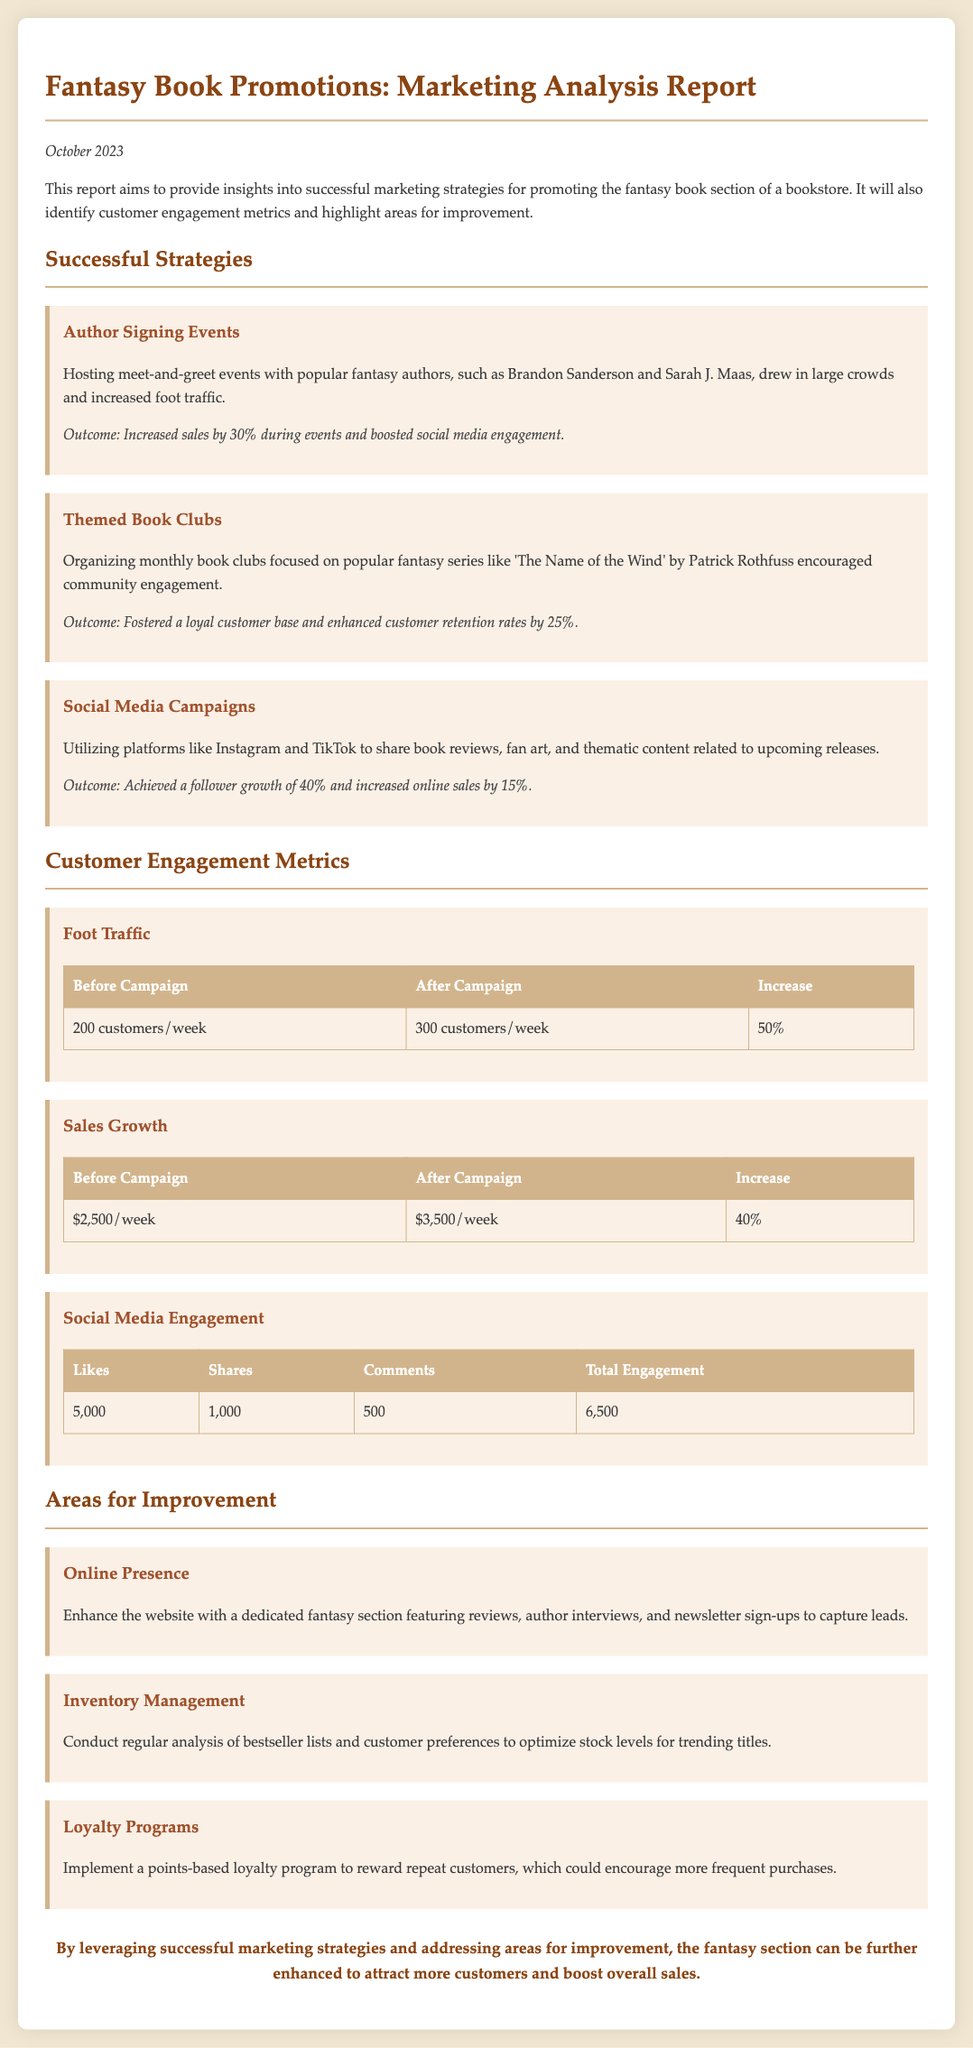what was the increase in foot traffic? The document states an increase of 50% in foot traffic after the marketing campaign.
Answer: 50% who are two popular fantasy authors mentioned? The report highlights Brandon Sanderson and Sarah J. Maas as popular fantasy authors.
Answer: Brandon Sanderson and Sarah J. Maas what is the outcome of the themed book clubs? Organizing themed book clubs has fostered a loyal customer base and enhanced customer retention rates.
Answer: Enhanced customer retention rates by 25% how much did sales grow after the campaign? The report indicates that sales grew from $2,500 to $3,500 per week, reflecting a direct increase.
Answer: 40% what area should improve according to the report? The report suggests that enhancing the online presence is a key area for improvement.
Answer: Online Presence what engagement metric achieved 6,500 total interactions? The social media engagement section tallies likes, shares, and comments to reach this total.
Answer: 6,500 what percentage did social media follower growth reach? After implementing social media campaigns, the report notes a significant follower growth of 40%.
Answer: 40% what is a proposed area for customer retention? The document mentions implementing a points-based loyalty program to encourage repeat purchases.
Answer: Loyalty Programs who hosted the met-and-greet events? The author signing events featured popular fantasy authors, including Brandon Sanderson.
Answer: Brandon Sanderson 